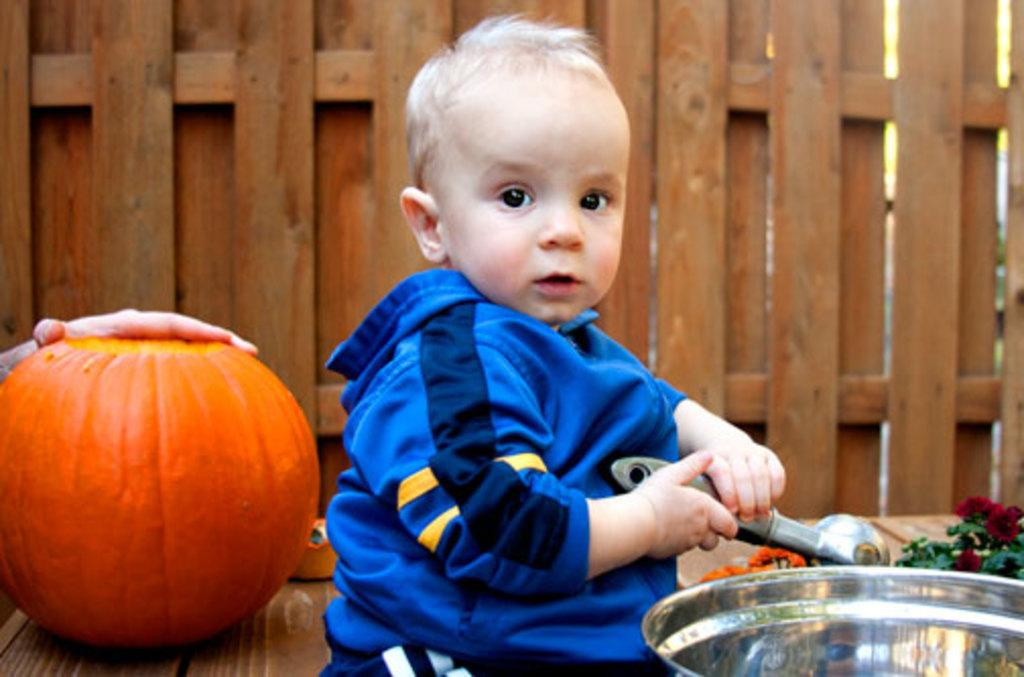What is the boy holding in the image? The boy is holding an object in the image. What can be seen in the background of the image? There is a wooden wall and a pumpkin in the background of the image. Can you describe the person's hand visible in the background? There is a person's hand visible in the background of the image. What type of container is present in the image? There is a container in the image. What kind of plant is in the image? There is a plant in the image. What joke is the queen telling to her son in the image? There is no queen or son present in the image, and therefore no such interaction can be observed. 